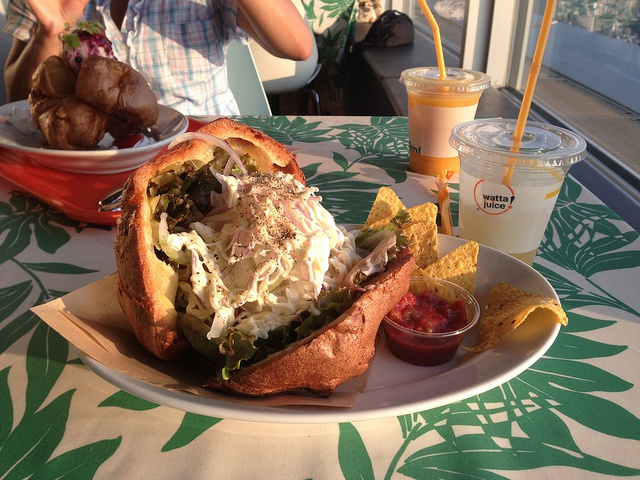Describe the objects in this image and their specific colors. I can see dining table in tan, gray, maroon, black, and darkgray tones, sandwich in tan, maroon, black, and brown tones, people in tan, gray, ivory, maroon, and black tones, cup in tan, darkgray, and gray tones, and cup in tan and brown tones in this image. 